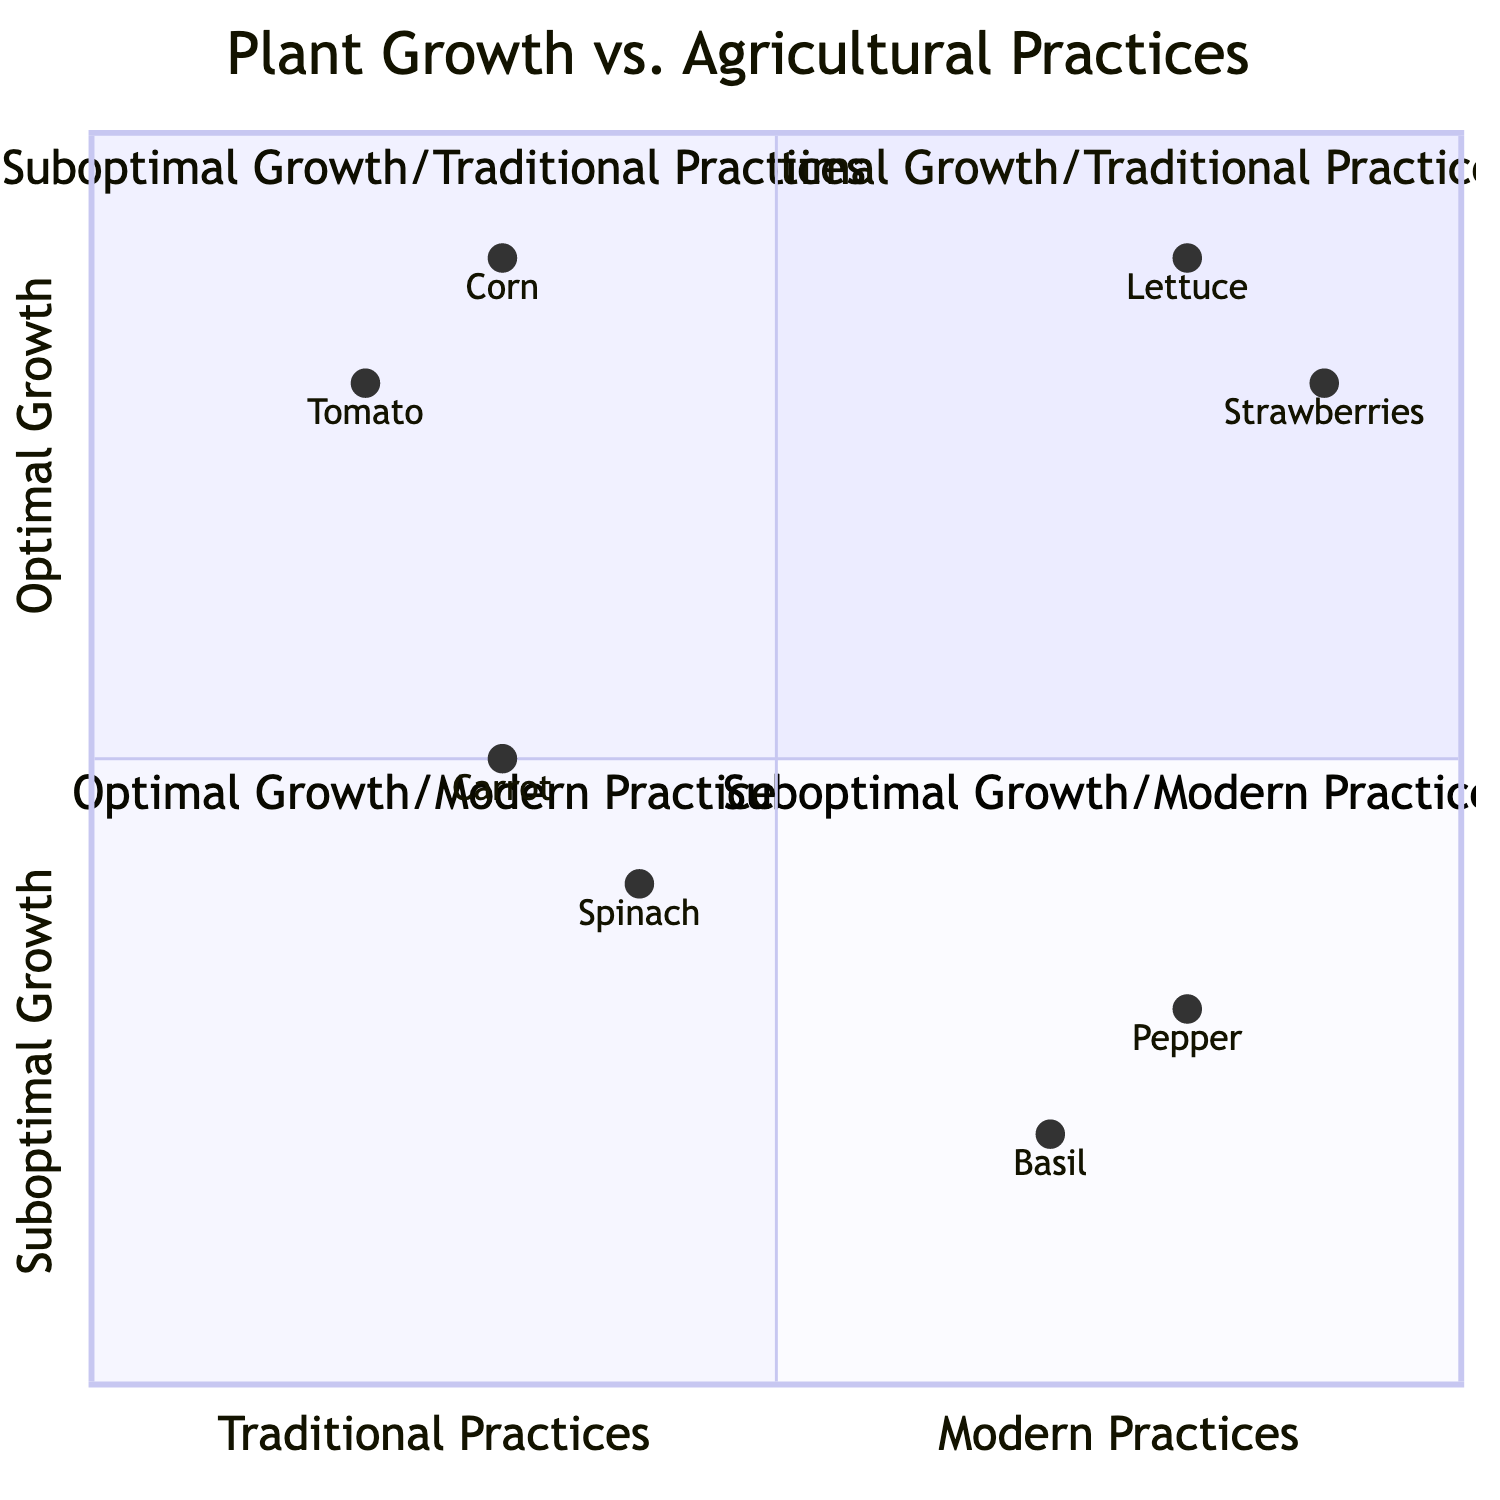What is the plant type located in Quadrant 1? Quadrant 1 is labeled "Optimal Growth/Traditional Practices". The elements listed under this quadrant are Tomato and Corn. The plant type that is named first, Tomato, is the answer.
Answer: Tomato What cultural practice is associated with Lettuce? Lettuce is located in Quadrant 3, which is "Optimal Growth/Modern Practices". The elements in this quadrant indicate that the cultural practice for Lettuce is Hydroponics.
Answer: Hydroponics Which light condition is associated with the Pepper plant? The Pepper plant is located in Quadrant 4, labeled "Suboptimal Growth/Modern Practices". The description indicates that the light condition for Pepper is Low-Intensity LED.
Answer: Low-Intensity LED How many plant types are listed under "Suboptimal Growth/Traditional Practices"? "Suboptimal Growth/Traditional Practices" is represented by Quadrant 2. There are two plant types listed here: Spinach and Carrot, totaling two plant types.
Answer: 2 Which quadrant has the highest yield plants overall? Quadrant 1 "Optimal Growth/Traditional Practices" and Quadrant 3 "Optimal Growth/Modern Practices" both contain plants with high yield. However, Quadrant 3 has more modern practice plant types, which typically indicates a potential for further optimization.
Answer: Quadrant 3 Which plant in Quadrant 4 has the lowest yield? In Quadrant 4, which is "Suboptimal Growth/Modern Practices", the plants listed are Basil and Pepper. Both have low yields, but Basil specifically shows a lower yield marked as Low.
Answer: Basil What is the light condition for plants in Quadrant 3? Quadrant 3 includes two plants: Lettuce and Strawberries. Both plant types are associated with advanced lighting methods—Lettuce uses LED Grow Light and Strawberries use Full Spectrum LED. Therefore, both plants are understood to grow optimally under modern lighting conditions.
Answer: LED Grow Light / Full Spectrum LED Which cultural practice is associated with Carrot? Carrot is categorized under Quadrant 2, "Suboptimal Growth/Traditional Practices". It mentions that the cultural practice for Carrot is Companion Planting.
Answer: Companion Planting 